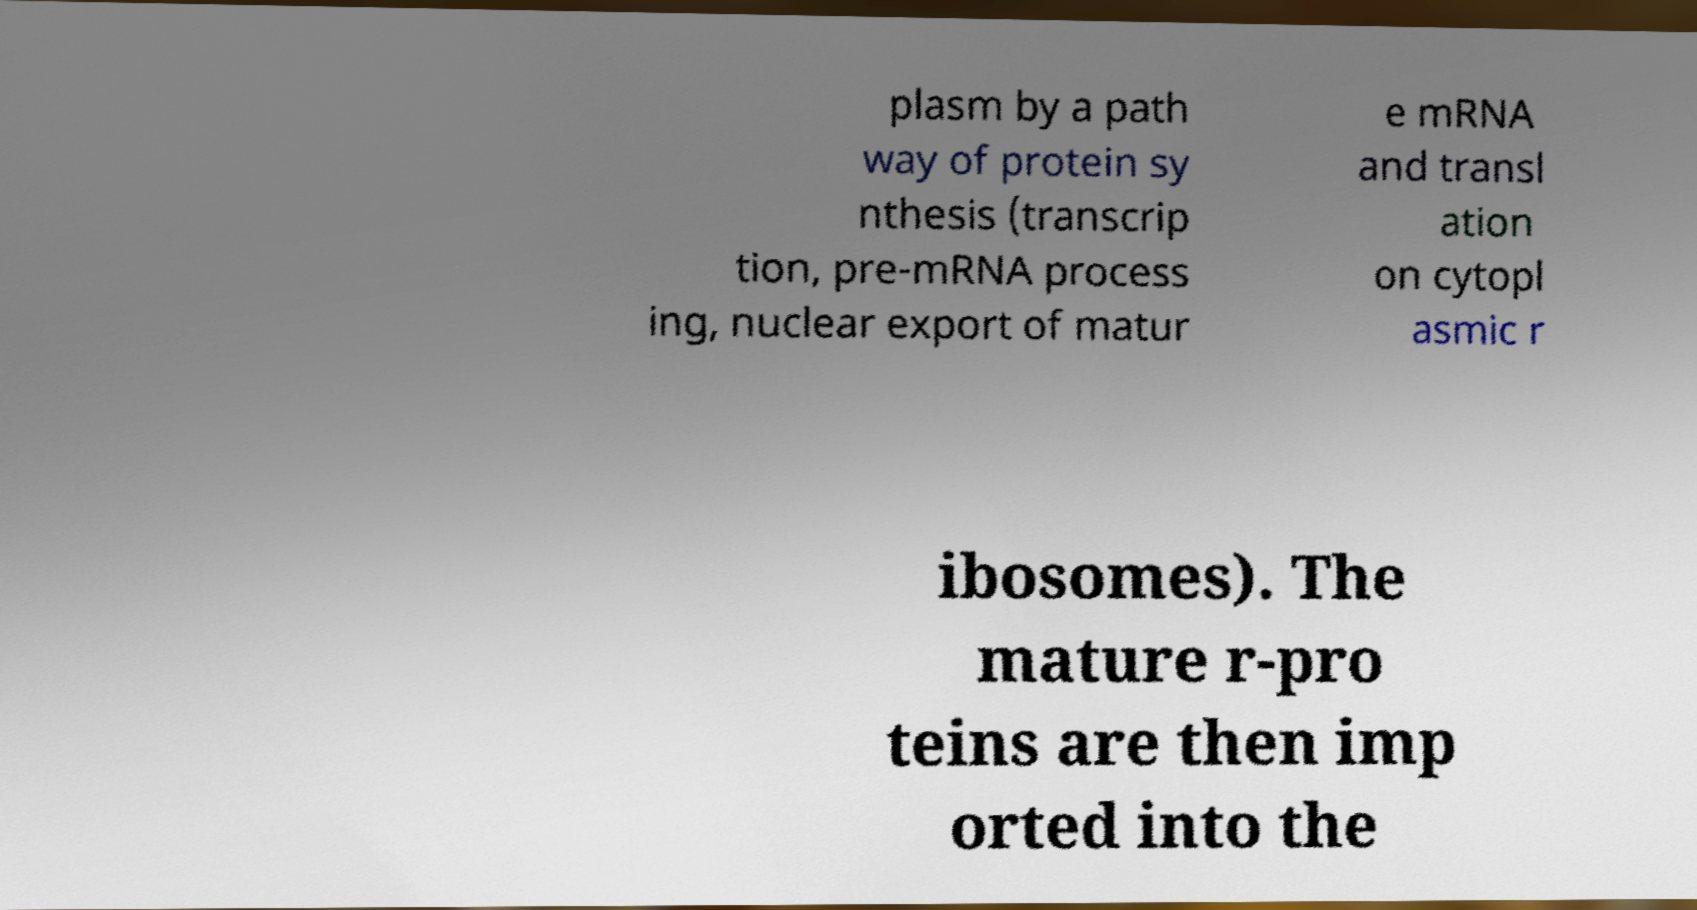Could you extract and type out the text from this image? plasm by a path way of protein sy nthesis (transcrip tion, pre-mRNA process ing, nuclear export of matur e mRNA and transl ation on cytopl asmic r ibosomes). The mature r-pro teins are then imp orted into the 